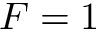<formula> <loc_0><loc_0><loc_500><loc_500>F = 1</formula> 